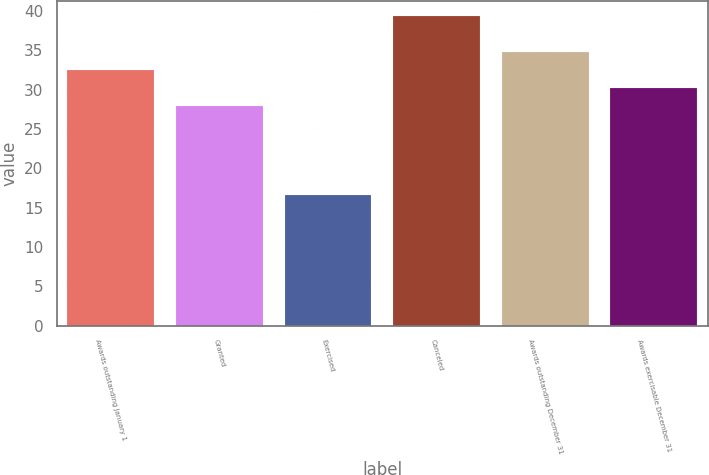<chart> <loc_0><loc_0><loc_500><loc_500><bar_chart><fcel>Awards outstanding January 1<fcel>Granted<fcel>Exercised<fcel>Canceled<fcel>Awards outstanding December 31<fcel>Awards exercisable December 31<nl><fcel>32.46<fcel>27.9<fcel>16.55<fcel>39.34<fcel>34.74<fcel>30.18<nl></chart> 